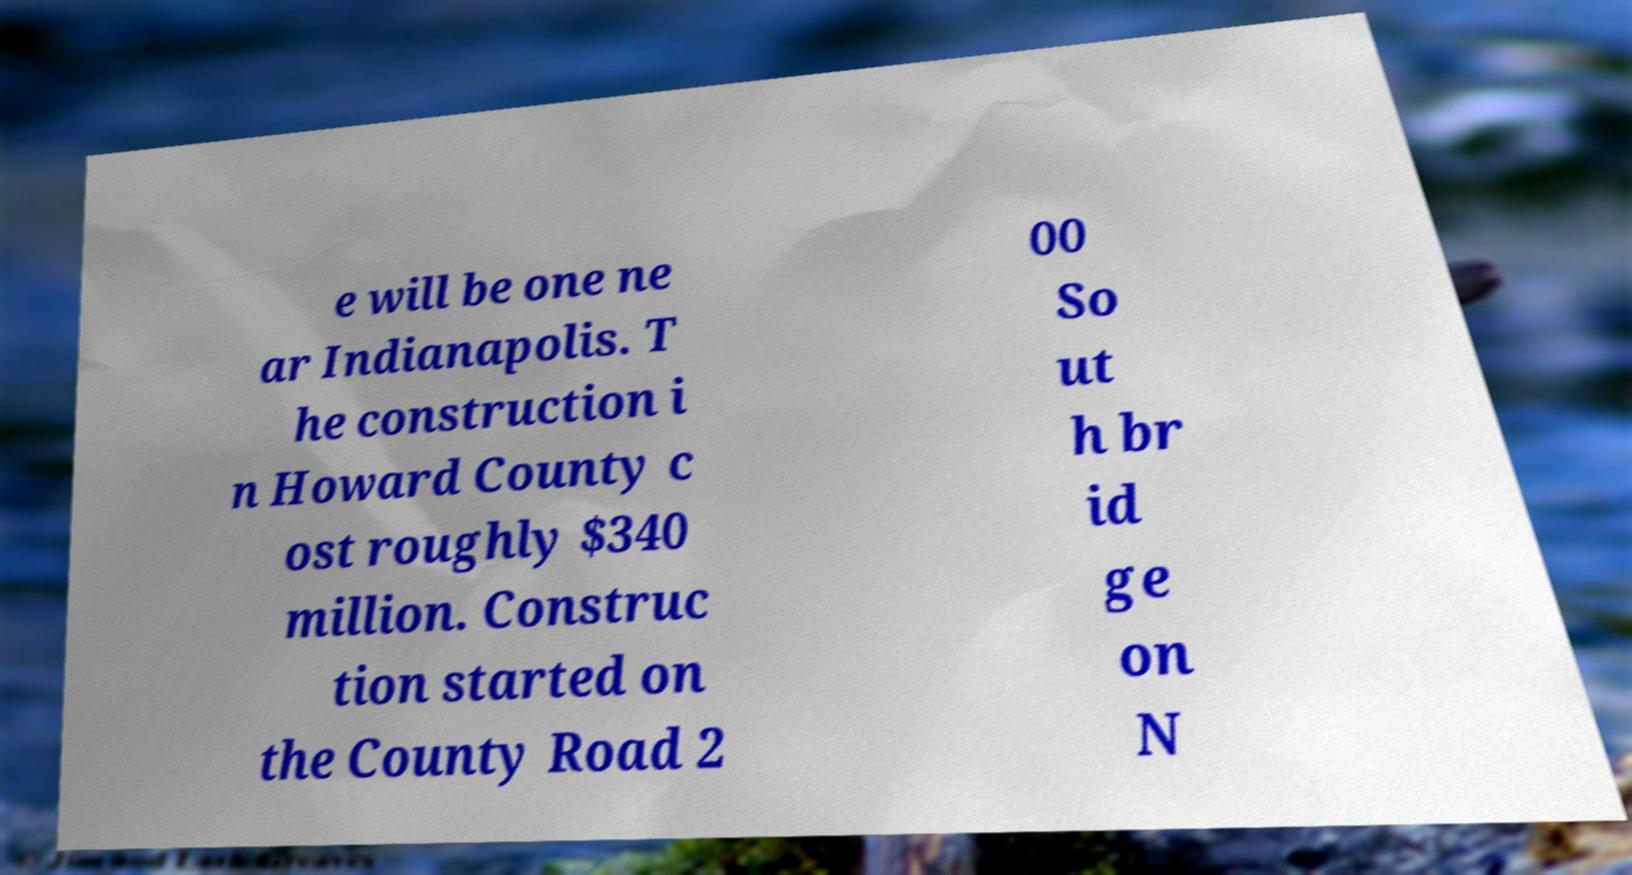Please read and relay the text visible in this image. What does it say? e will be one ne ar Indianapolis. T he construction i n Howard County c ost roughly $340 million. Construc tion started on the County Road 2 00 So ut h br id ge on N 